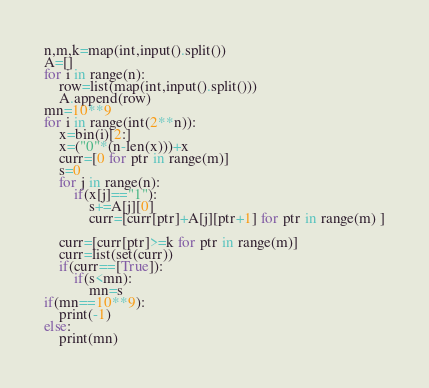<code> <loc_0><loc_0><loc_500><loc_500><_Python_>
n,m,k=map(int,input().split())
A=[]
for i in range(n):
    row=list(map(int,input().split()))
    A.append(row)
mn=10**9
for i in range(int(2**n)):
    x=bin(i)[2:]
    x=("0"*(n-len(x)))+x
    curr=[0 for ptr in range(m)]
    s=0
    for j in range(n):
        if(x[j]=="1"):
            s+=A[j][0]
            curr=[curr[ptr]+A[j][ptr+1] for ptr in range(m) ]

    curr=[curr[ptr]>=k for ptr in range(m)]
    curr=list(set(curr))
    if(curr==[True]):
        if(s<mn):
            mn=s
if(mn==10**9):
    print(-1)
else:
    print(mn)</code> 